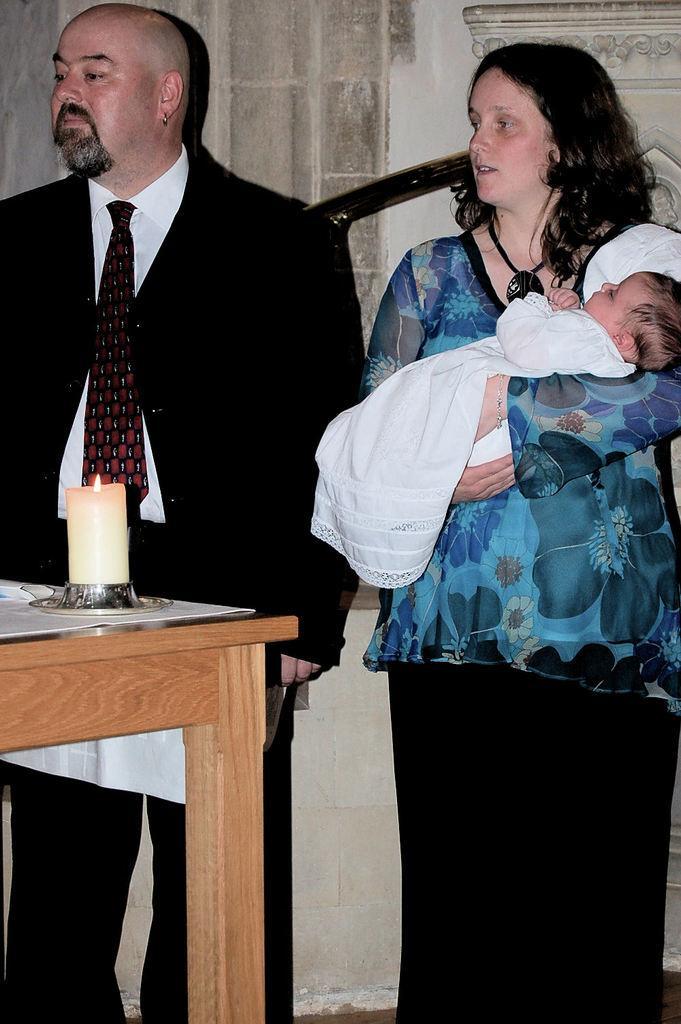Describe this image in one or two sentences. In this picture we can see man wore blazer, tie and beside to his woman carrying baby with her hand and in front of them there is table and on table we can see candle and in background we can see wall. 